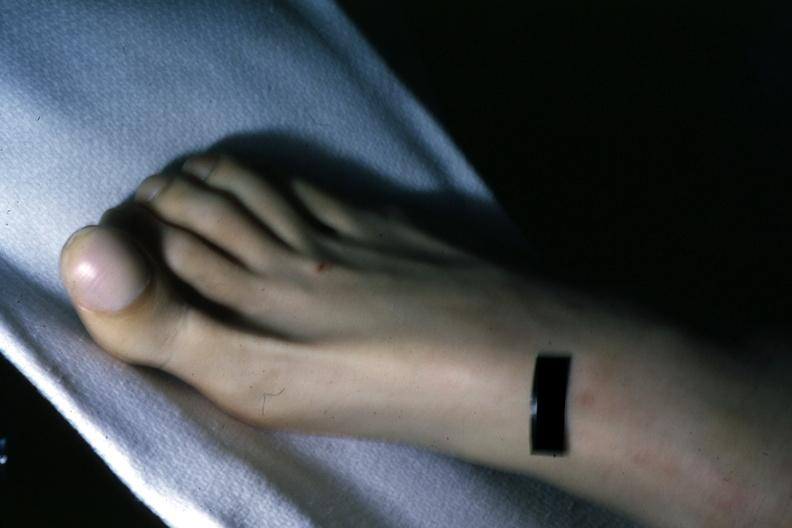does this great toe show clubbing?
Answer the question using a single word or phrase. Yes 